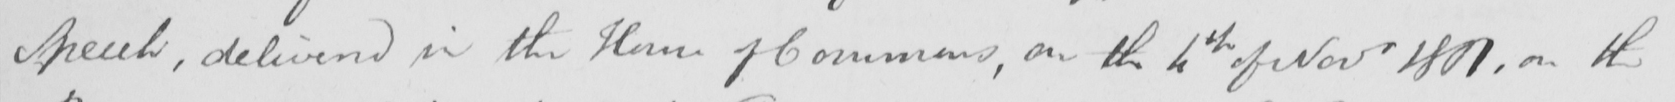Transcribe the text shown in this historical manuscript line. speech , delivered in the House of Commons , on the 4th of Novr 1801 , on the 